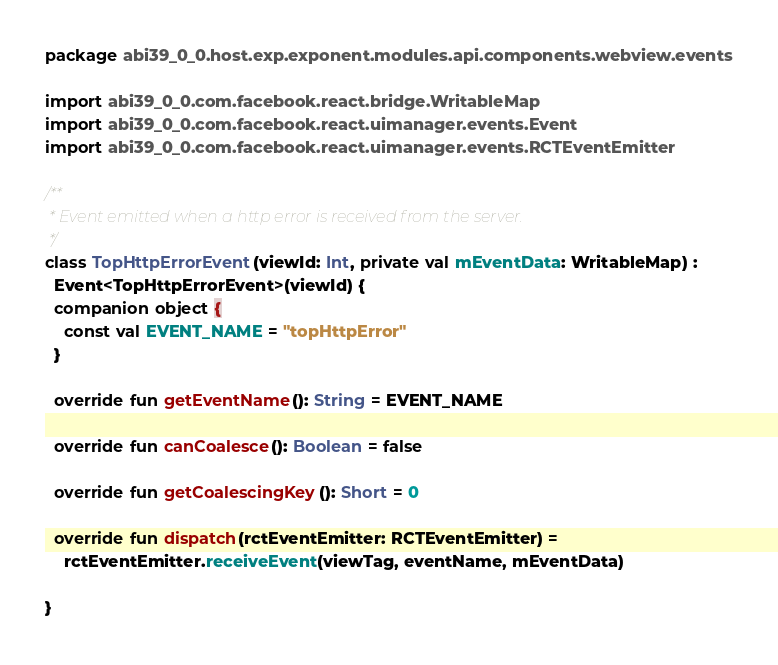Convert code to text. <code><loc_0><loc_0><loc_500><loc_500><_Kotlin_>package abi39_0_0.host.exp.exponent.modules.api.components.webview.events

import abi39_0_0.com.facebook.react.bridge.WritableMap
import abi39_0_0.com.facebook.react.uimanager.events.Event
import abi39_0_0.com.facebook.react.uimanager.events.RCTEventEmitter

/**
 * Event emitted when a http error is received from the server.
 */
class TopHttpErrorEvent(viewId: Int, private val mEventData: WritableMap) :
  Event<TopHttpErrorEvent>(viewId) {
  companion object {
    const val EVENT_NAME = "topHttpError"
  }

  override fun getEventName(): String = EVENT_NAME

  override fun canCoalesce(): Boolean = false

  override fun getCoalescingKey(): Short = 0

  override fun dispatch(rctEventEmitter: RCTEventEmitter) =
    rctEventEmitter.receiveEvent(viewTag, eventName, mEventData)

}
</code> 